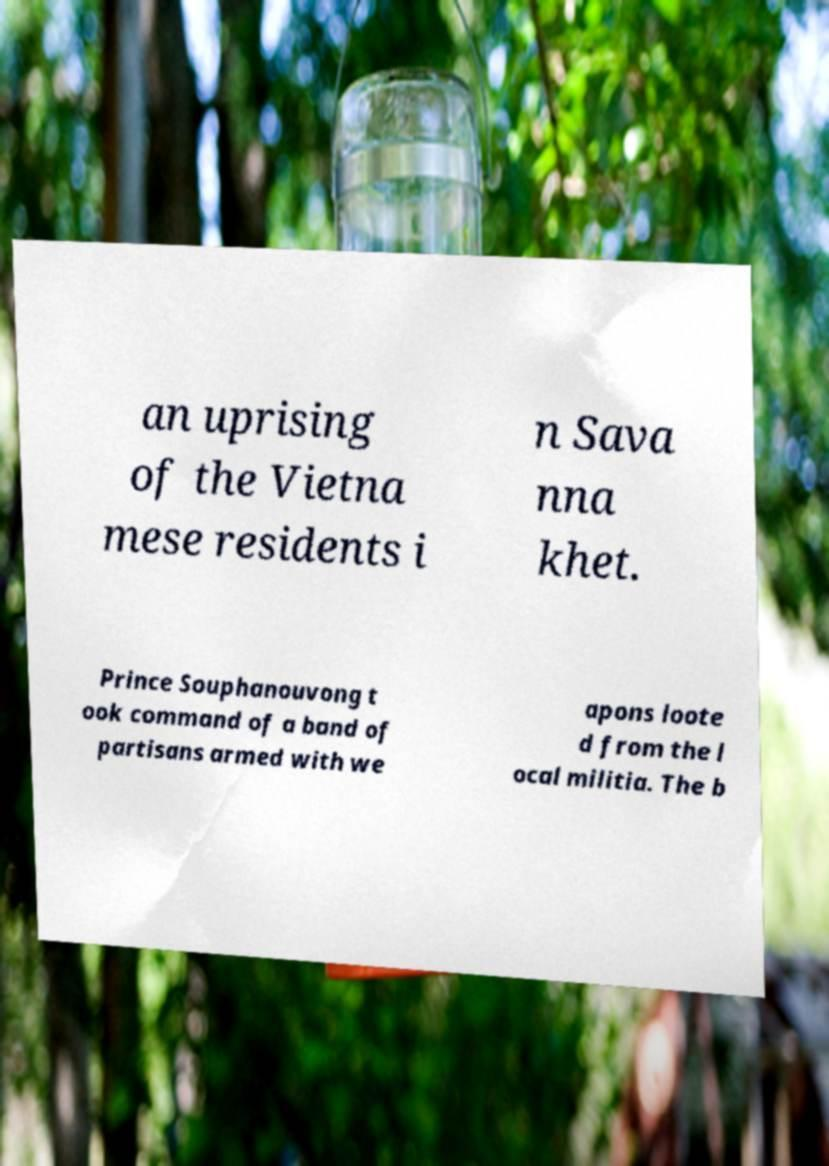There's text embedded in this image that I need extracted. Can you transcribe it verbatim? an uprising of the Vietna mese residents i n Sava nna khet. Prince Souphanouvong t ook command of a band of partisans armed with we apons loote d from the l ocal militia. The b 